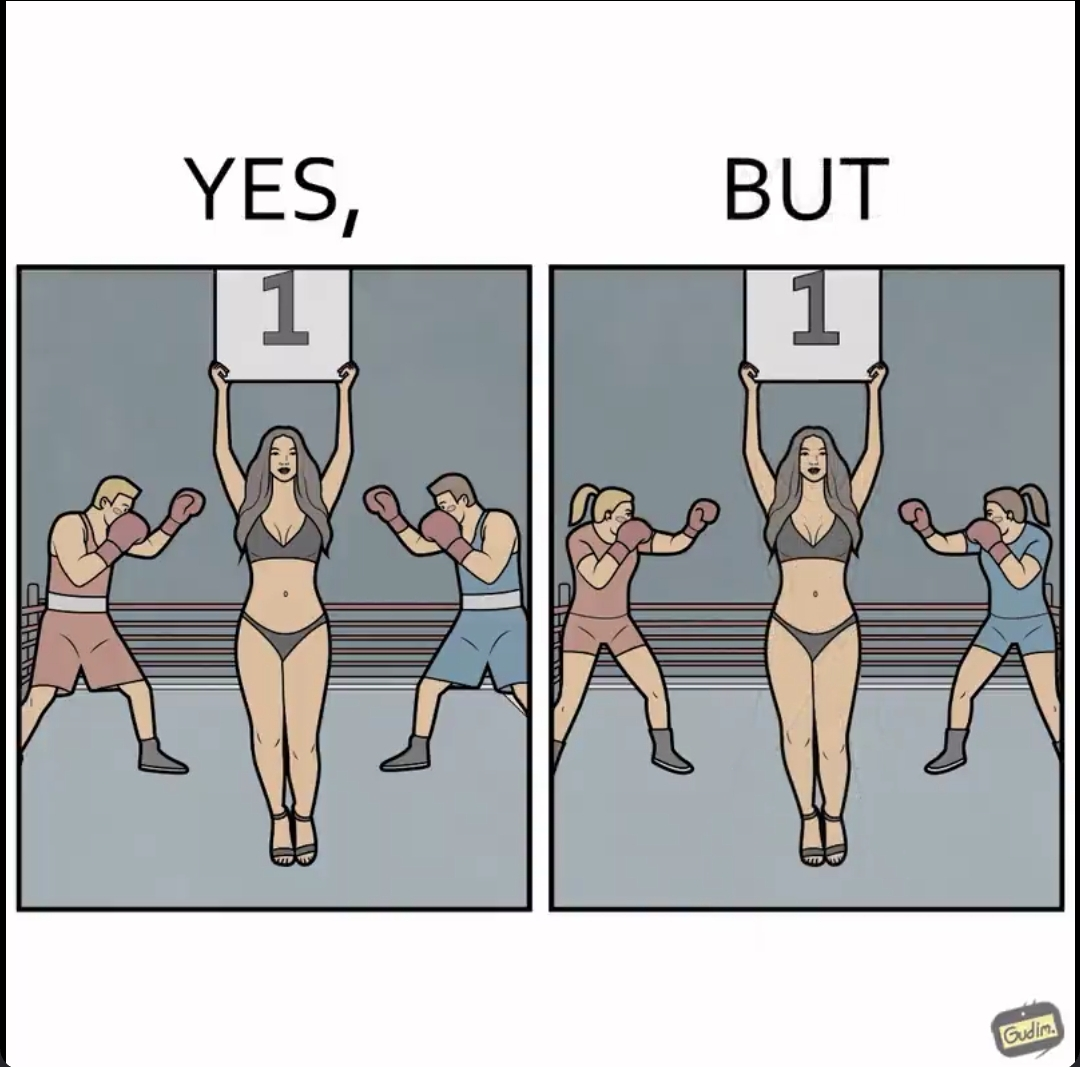Is this image satirical or non-satirical? Yes, this image is satirical. 